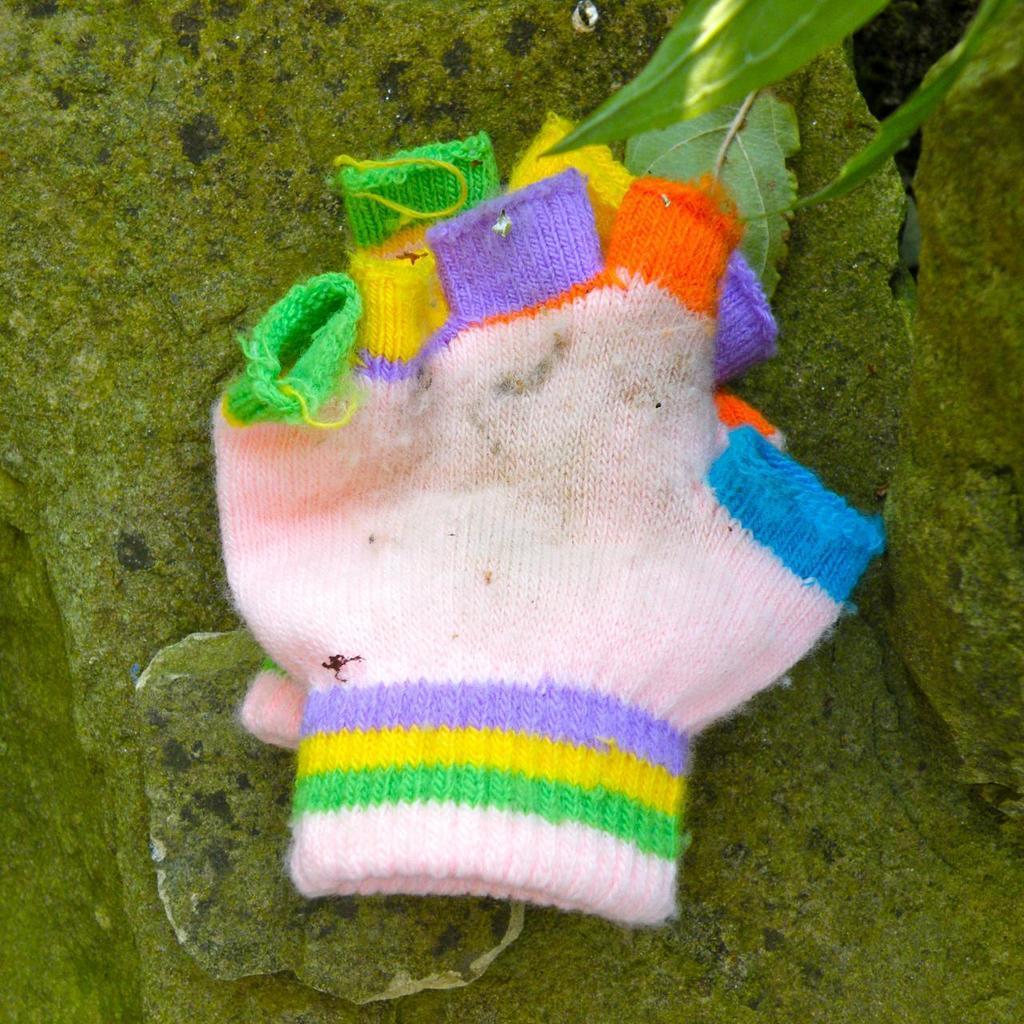Please provide a concise description of this image. On the green surface there are two colorful gloves. Also there are leaves in the image. 